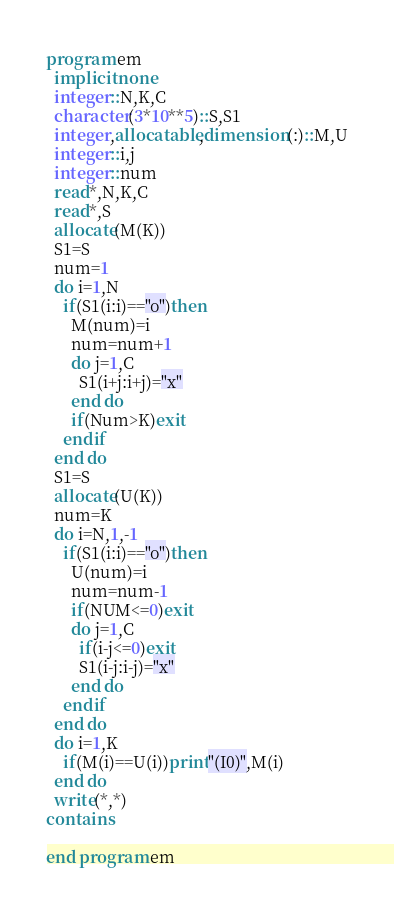<code> <loc_0><loc_0><loc_500><loc_500><_FORTRAN_>program em
  implicit none
  integer::N,K,C
  character(3*10**5)::S,S1
  integer,allocatable,dimension(:)::M,U
  integer::i,j
  integer::num
  read*,N,K,C
  read*,S
  allocate(M(K))
  S1=S
  num=1
  do i=1,N
    if(S1(i:i)=="o")then        
      M(num)=i
      num=num+1
      do j=1,C
        S1(i+j:i+j)="x"
      end do
      if(Num>K)exit
    endif
  end do
  S1=S
  allocate(U(K))
  num=K
  do i=N,1,-1
    if(S1(i:i)=="o")then
      U(num)=i
      num=num-1
      if(NUM<=0)exit
      do j=1,C
        if(i-j<=0)exit
        S1(i-j:i-j)="x"
      end do
    endif
  end do
  do i=1,K
    if(M(i)==U(i))print"(I0)",M(i)
  end do
  write(*,*)
contains

end program em</code> 